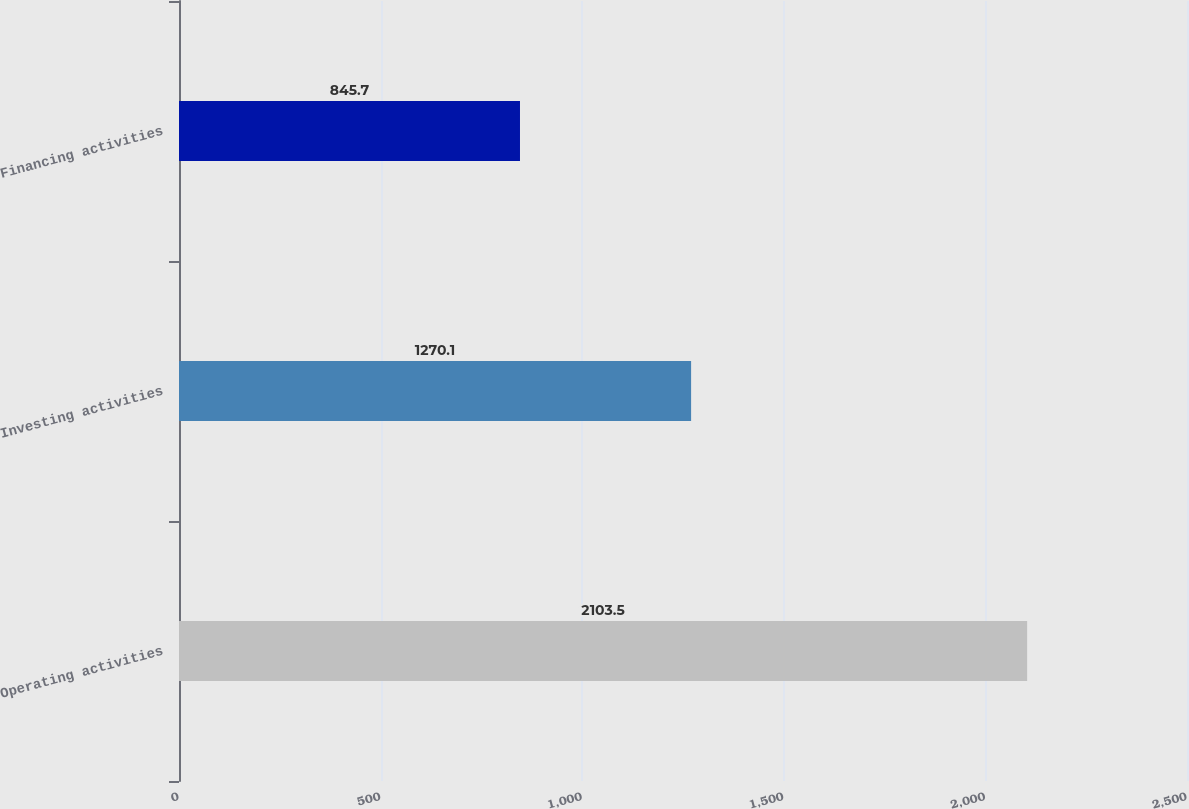Convert chart to OTSL. <chart><loc_0><loc_0><loc_500><loc_500><bar_chart><fcel>Operating activities<fcel>Investing activities<fcel>Financing activities<nl><fcel>2103.5<fcel>1270.1<fcel>845.7<nl></chart> 